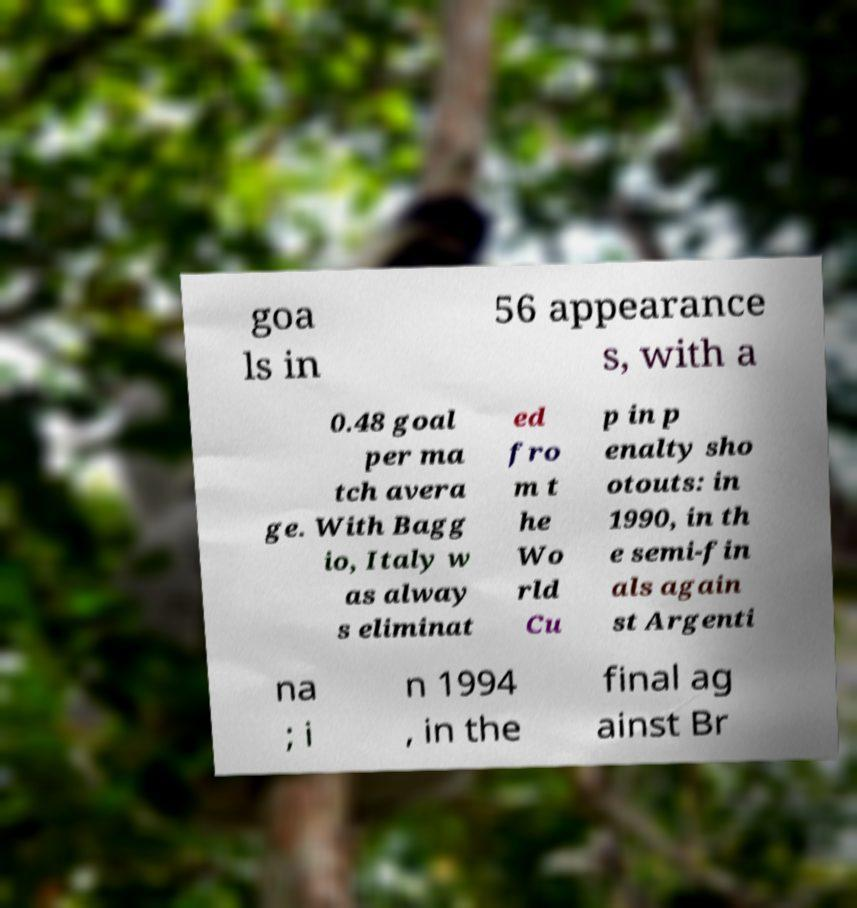Please read and relay the text visible in this image. What does it say? goa ls in 56 appearance s, with a 0.48 goal per ma tch avera ge. With Bagg io, Italy w as alway s eliminat ed fro m t he Wo rld Cu p in p enalty sho otouts: in 1990, in th e semi-fin als again st Argenti na ; i n 1994 , in the final ag ainst Br 